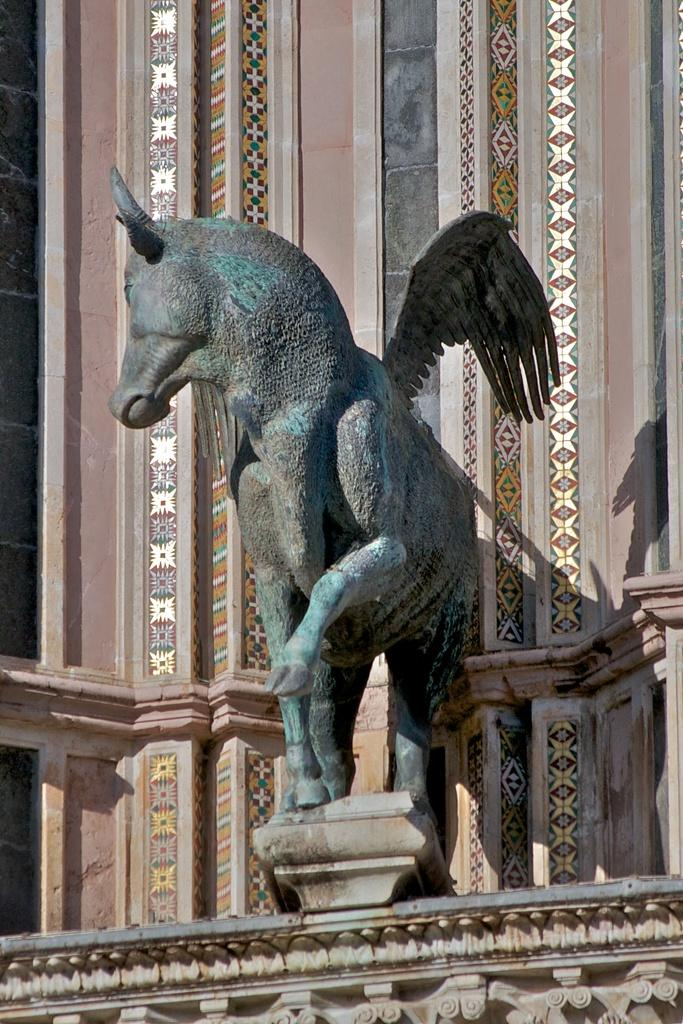What type of statue is depicted in the image? There is a statue of a horse with wings in the image. Where is the statue located? The statue is on a platform. What can be seen in the background of the image? There is a wall in the background of the image. Are there any decorative elements on the wall? Yes, there are designs on the wall. What type of friction can be observed between the statue and the platform in the image? There is no friction observable between the statue and the platform in the image, as the statue is a stationary object. What knowledge does the daughter gain from observing the statue in the image? There is no daughter present in the image, so it is not possible to determine what knowledge she might gain from observing the statue. 